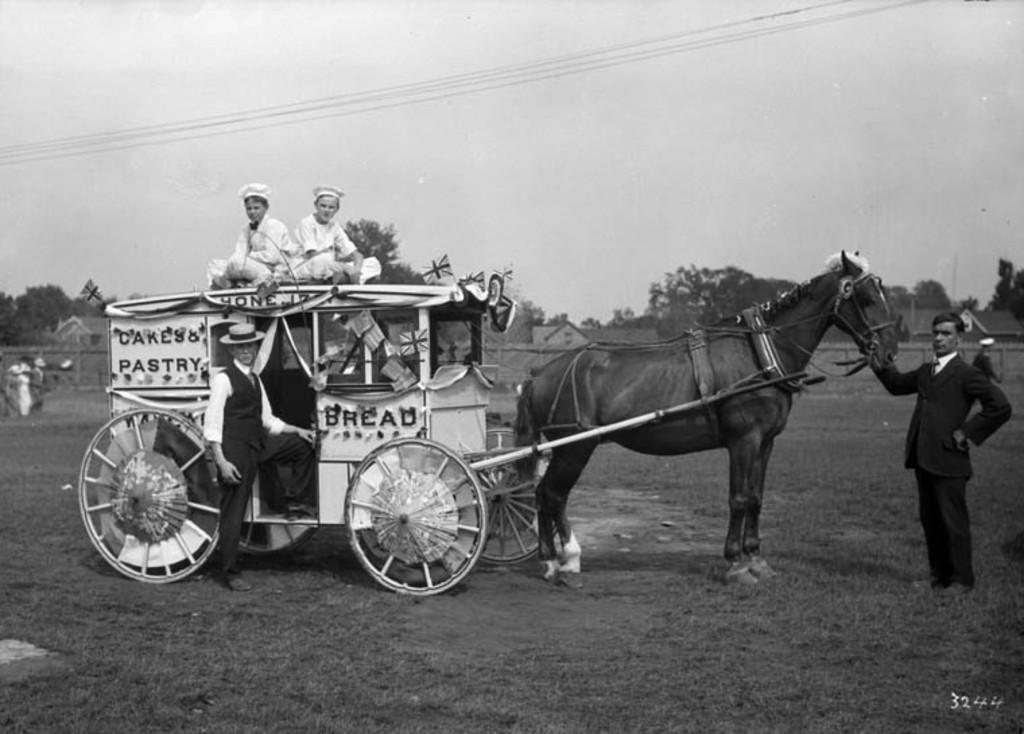What type of vehicle is in the image? There is a bullock cart in the image. Who or what is inside the bullock cart? There are people in the bullock cart. What is the role of the person in front of the horse? There is a person in front of the horse, likely guiding or leading it. Can you see any jellyfish in the image? No, there are no jellyfish present in the image. What event is about to start in the image? There is no indication of an event starting in the image. 